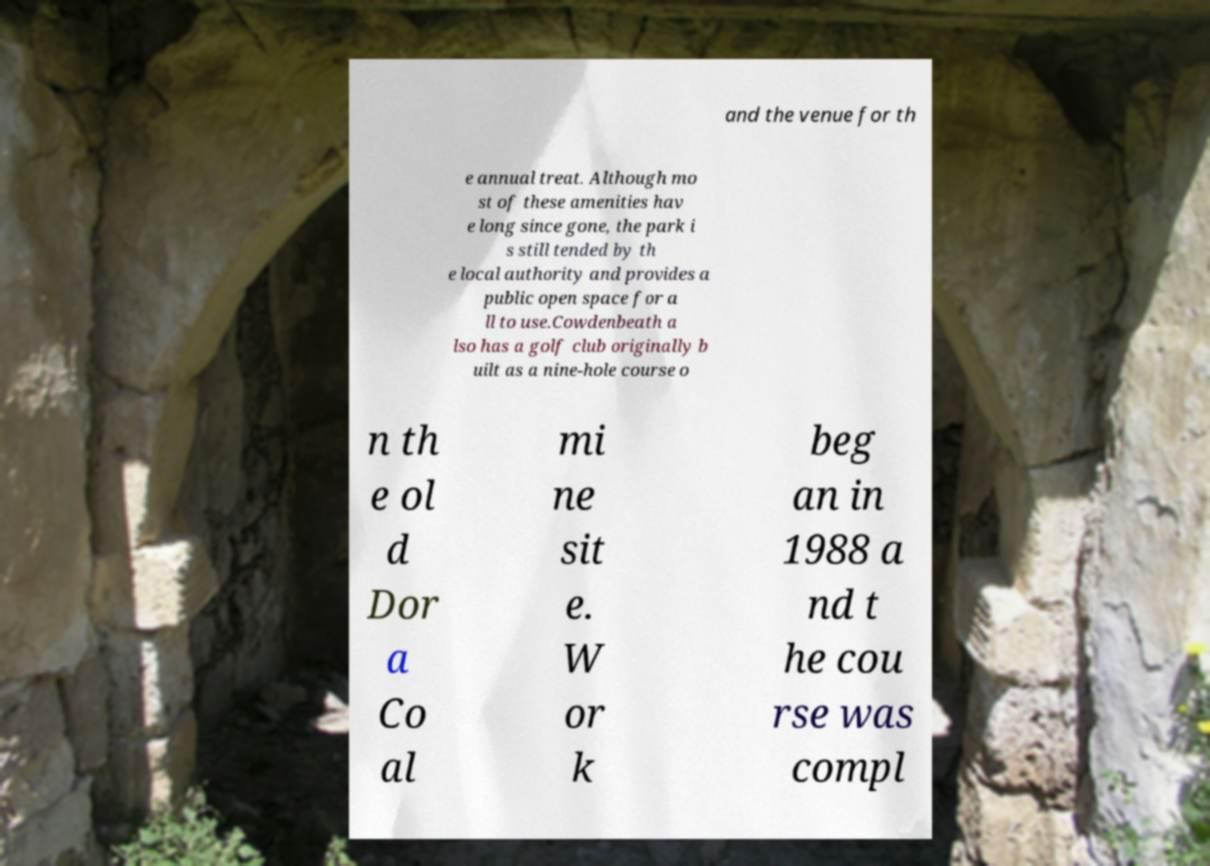Can you read and provide the text displayed in the image?This photo seems to have some interesting text. Can you extract and type it out for me? and the venue for th e annual treat. Although mo st of these amenities hav e long since gone, the park i s still tended by th e local authority and provides a public open space for a ll to use.Cowdenbeath a lso has a golf club originally b uilt as a nine-hole course o n th e ol d Dor a Co al mi ne sit e. W or k beg an in 1988 a nd t he cou rse was compl 